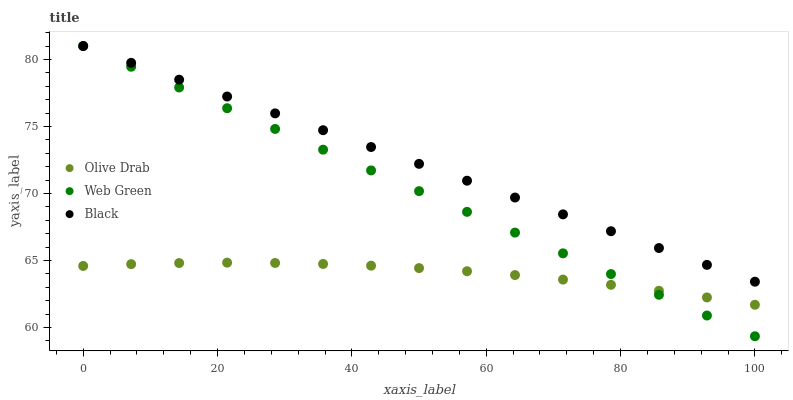Does Olive Drab have the minimum area under the curve?
Answer yes or no. Yes. Does Black have the maximum area under the curve?
Answer yes or no. Yes. Does Web Green have the minimum area under the curve?
Answer yes or no. No. Does Web Green have the maximum area under the curve?
Answer yes or no. No. Is Web Green the smoothest?
Answer yes or no. Yes. Is Olive Drab the roughest?
Answer yes or no. Yes. Is Olive Drab the smoothest?
Answer yes or no. No. Is Web Green the roughest?
Answer yes or no. No. Does Web Green have the lowest value?
Answer yes or no. Yes. Does Olive Drab have the lowest value?
Answer yes or no. No. Does Web Green have the highest value?
Answer yes or no. Yes. Does Olive Drab have the highest value?
Answer yes or no. No. Is Olive Drab less than Black?
Answer yes or no. Yes. Is Black greater than Olive Drab?
Answer yes or no. Yes. Does Olive Drab intersect Web Green?
Answer yes or no. Yes. Is Olive Drab less than Web Green?
Answer yes or no. No. Is Olive Drab greater than Web Green?
Answer yes or no. No. Does Olive Drab intersect Black?
Answer yes or no. No. 